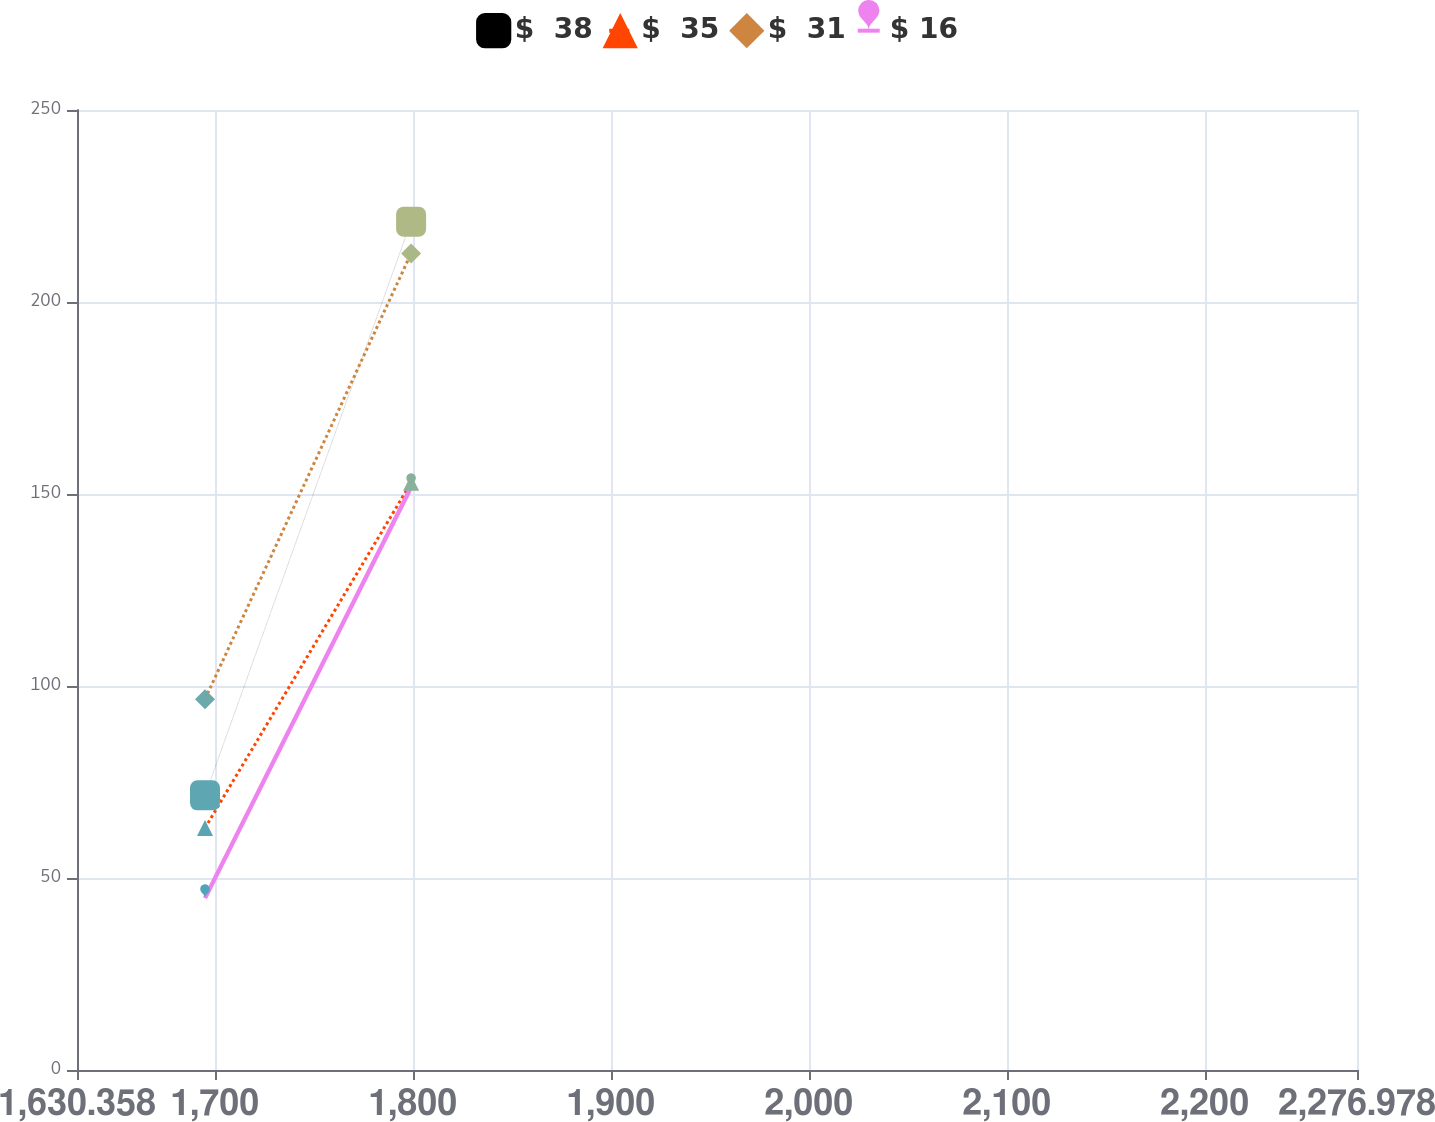<chart> <loc_0><loc_0><loc_500><loc_500><line_chart><ecel><fcel>$  38<fcel>$  35<fcel>$  31<fcel>$ 16<nl><fcel>1695.02<fcel>71.52<fcel>63.01<fcel>96.58<fcel>44.76<nl><fcel>1799.14<fcel>220.93<fcel>152.96<fcel>212.65<fcel>151.77<nl><fcel>2280.87<fcel>619.15<fcel>583.08<fcel>445.87<fcel>408.22<nl><fcel>2341.64<fcel>275.69<fcel>204.97<fcel>177.72<fcel>81.11<nl></chart> 